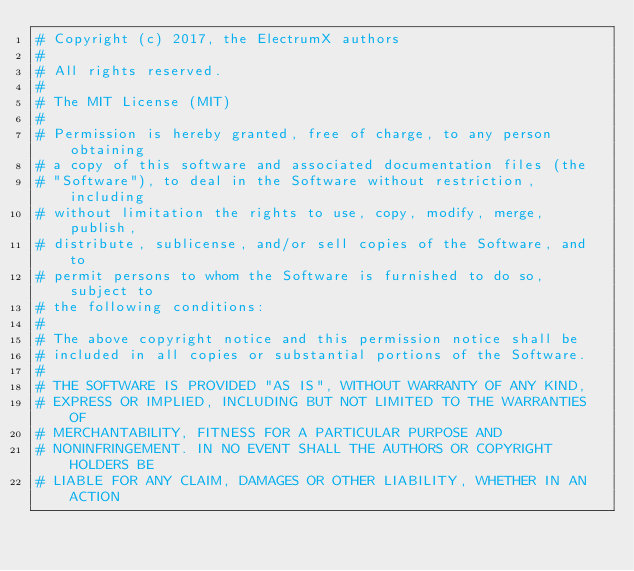<code> <loc_0><loc_0><loc_500><loc_500><_Python_># Copyright (c) 2017, the ElectrumX authors
#
# All rights reserved.
#
# The MIT License (MIT)
#
# Permission is hereby granted, free of charge, to any person obtaining
# a copy of this software and associated documentation files (the
# "Software"), to deal in the Software without restriction, including
# without limitation the rights to use, copy, modify, merge, publish,
# distribute, sublicense, and/or sell copies of the Software, and to
# permit persons to whom the Software is furnished to do so, subject to
# the following conditions:
#
# The above copyright notice and this permission notice shall be
# included in all copies or substantial portions of the Software.
#
# THE SOFTWARE IS PROVIDED "AS IS", WITHOUT WARRANTY OF ANY KIND,
# EXPRESS OR IMPLIED, INCLUDING BUT NOT LIMITED TO THE WARRANTIES OF
# MERCHANTABILITY, FITNESS FOR A PARTICULAR PURPOSE AND
# NONINFRINGEMENT. IN NO EVENT SHALL THE AUTHORS OR COPYRIGHT HOLDERS BE
# LIABLE FOR ANY CLAIM, DAMAGES OR OTHER LIABILITY, WHETHER IN AN ACTION</code> 